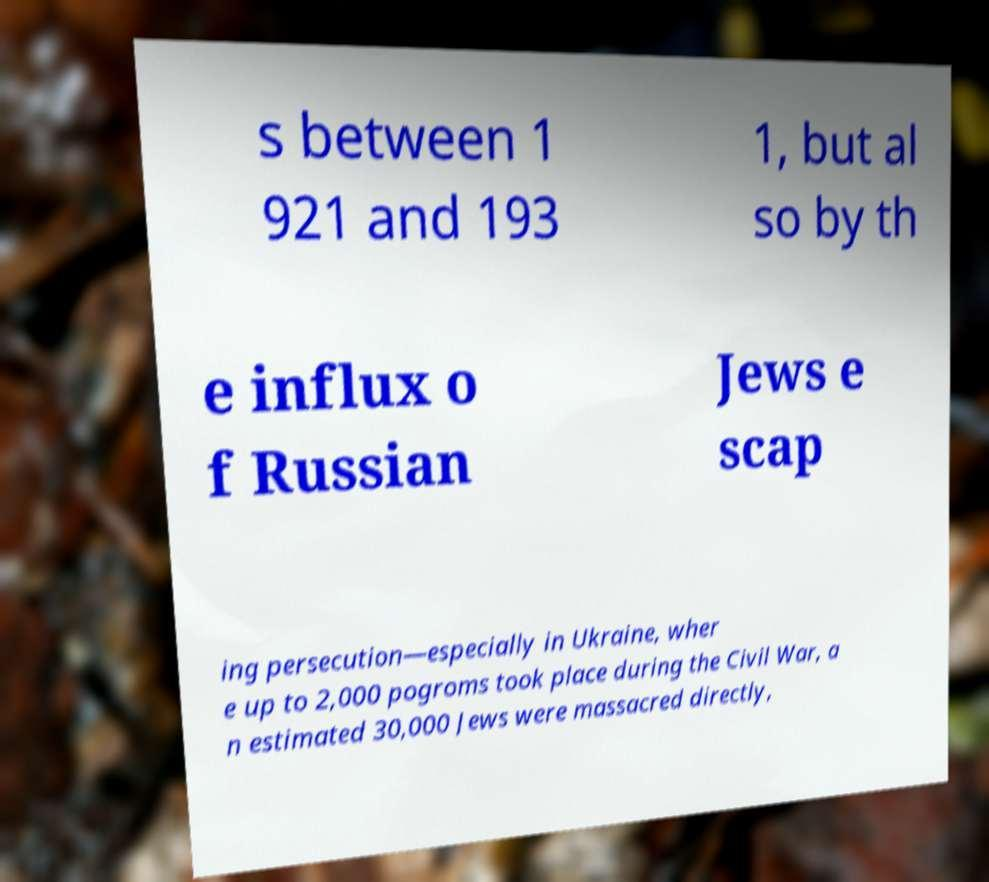Can you read and provide the text displayed in the image?This photo seems to have some interesting text. Can you extract and type it out for me? s between 1 921 and 193 1, but al so by th e influx o f Russian Jews e scap ing persecution—especially in Ukraine, wher e up to 2,000 pogroms took place during the Civil War, a n estimated 30,000 Jews were massacred directly, 